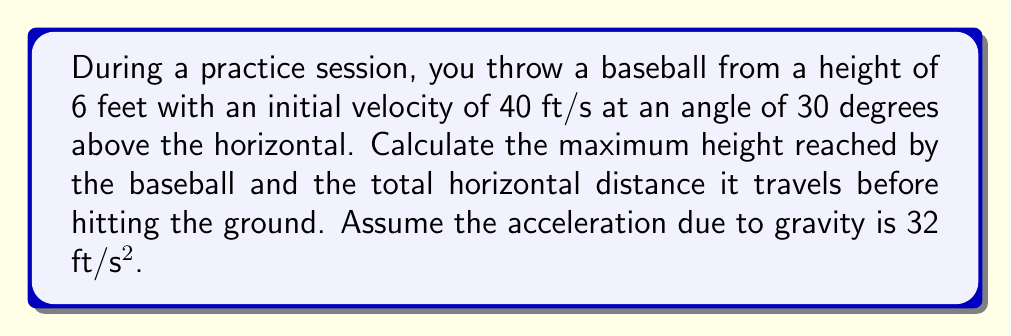Teach me how to tackle this problem. Let's approach this step-by-step using quadratic equations:

1) First, we need to break down the initial velocity into horizontal and vertical components:
   $v_x = 40 \cos(30°) = 40 \cdot \frac{\sqrt{3}}{2} \approx 34.64$ ft/s
   $v_y = 40 \sin(30°) = 40 \cdot \frac{1}{2} = 20$ ft/s

2) The horizontal motion is constant, so we only need to focus on the vertical motion for the quadratic equation.

3) The vertical motion is described by the equation:
   $y = -16t^2 + 20t + 6$
   Where -16 comes from $-\frac{1}{2}g = -\frac{1}{2}(32)$, 20 is the initial vertical velocity, and 6 is the initial height.

4) To find the maximum height, we need to find the vertex of this parabola:
   $t_{max} = -\frac{b}{2a} = -\frac{20}{2(-16)} = \frac{5}{8} = 0.625$ seconds

5) Plugging this time back into our equation:
   $y_{max} = -16(0.625)^2 + 20(0.625) + 6 = 12.25$ feet

6) For the total horizontal distance, we need to find when the ball hits the ground (y = 0):
   $0 = -16t^2 + 20t + 6$
   $16t^2 - 20t - 6 = 0$

7) Using the quadratic formula: $t = \frac{-b \pm \sqrt{b^2 - 4ac}}{2a}$
   $t = \frac{20 \pm \sqrt{400 + 384}}{32} = \frac{20 \pm \sqrt{784}}{32} = \frac{20 \pm 28}{32}$

8) We want the positive solution: $t = \frac{48}{32} = 1.5$ seconds

9) The horizontal distance is then:
   $d = v_x \cdot t = 34.64 \cdot 1.5 \approx 51.96$ feet

Therefore, the maximum height is 12.25 feet, and the total horizontal distance is approximately 51.96 feet.
Answer: Maximum height: 12.25 ft; Horizontal distance: 51.96 ft 